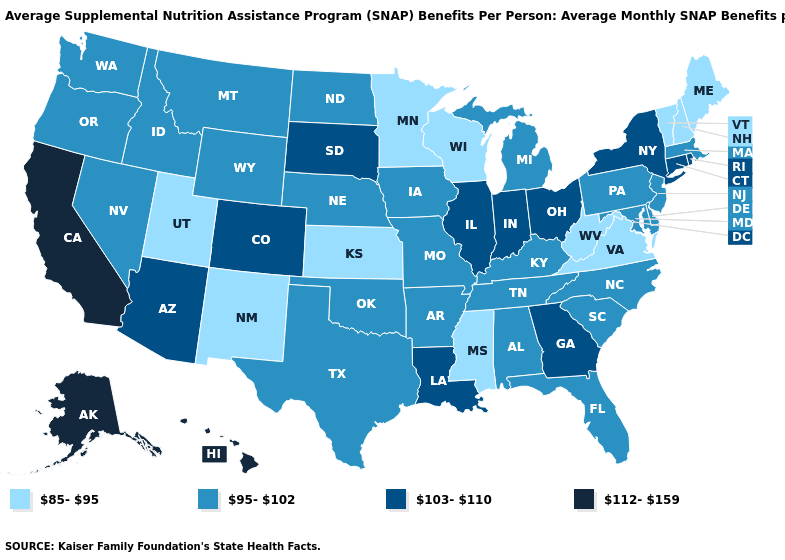Among the states that border Massachusetts , does New York have the lowest value?
Write a very short answer. No. Among the states that border Vermont , does New York have the lowest value?
Write a very short answer. No. Name the states that have a value in the range 112-159?
Keep it brief. Alaska, California, Hawaii. Does Wisconsin have the lowest value in the MidWest?
Concise answer only. Yes. Among the states that border Nebraska , does South Dakota have the highest value?
Concise answer only. Yes. What is the highest value in the USA?
Short answer required. 112-159. Is the legend a continuous bar?
Write a very short answer. No. Name the states that have a value in the range 103-110?
Be succinct. Arizona, Colorado, Connecticut, Georgia, Illinois, Indiana, Louisiana, New York, Ohio, Rhode Island, South Dakota. Name the states that have a value in the range 112-159?
Be succinct. Alaska, California, Hawaii. What is the lowest value in the Northeast?
Be succinct. 85-95. Name the states that have a value in the range 95-102?
Give a very brief answer. Alabama, Arkansas, Delaware, Florida, Idaho, Iowa, Kentucky, Maryland, Massachusetts, Michigan, Missouri, Montana, Nebraska, Nevada, New Jersey, North Carolina, North Dakota, Oklahoma, Oregon, Pennsylvania, South Carolina, Tennessee, Texas, Washington, Wyoming. How many symbols are there in the legend?
Answer briefly. 4. Does Kansas have the same value as New Hampshire?
Quick response, please. Yes. Name the states that have a value in the range 103-110?
Concise answer only. Arizona, Colorado, Connecticut, Georgia, Illinois, Indiana, Louisiana, New York, Ohio, Rhode Island, South Dakota. Does Nevada have the same value as California?
Give a very brief answer. No. 